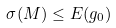<formula> <loc_0><loc_0><loc_500><loc_500>\sigma ( M ) \leq E ( g _ { 0 } )</formula> 